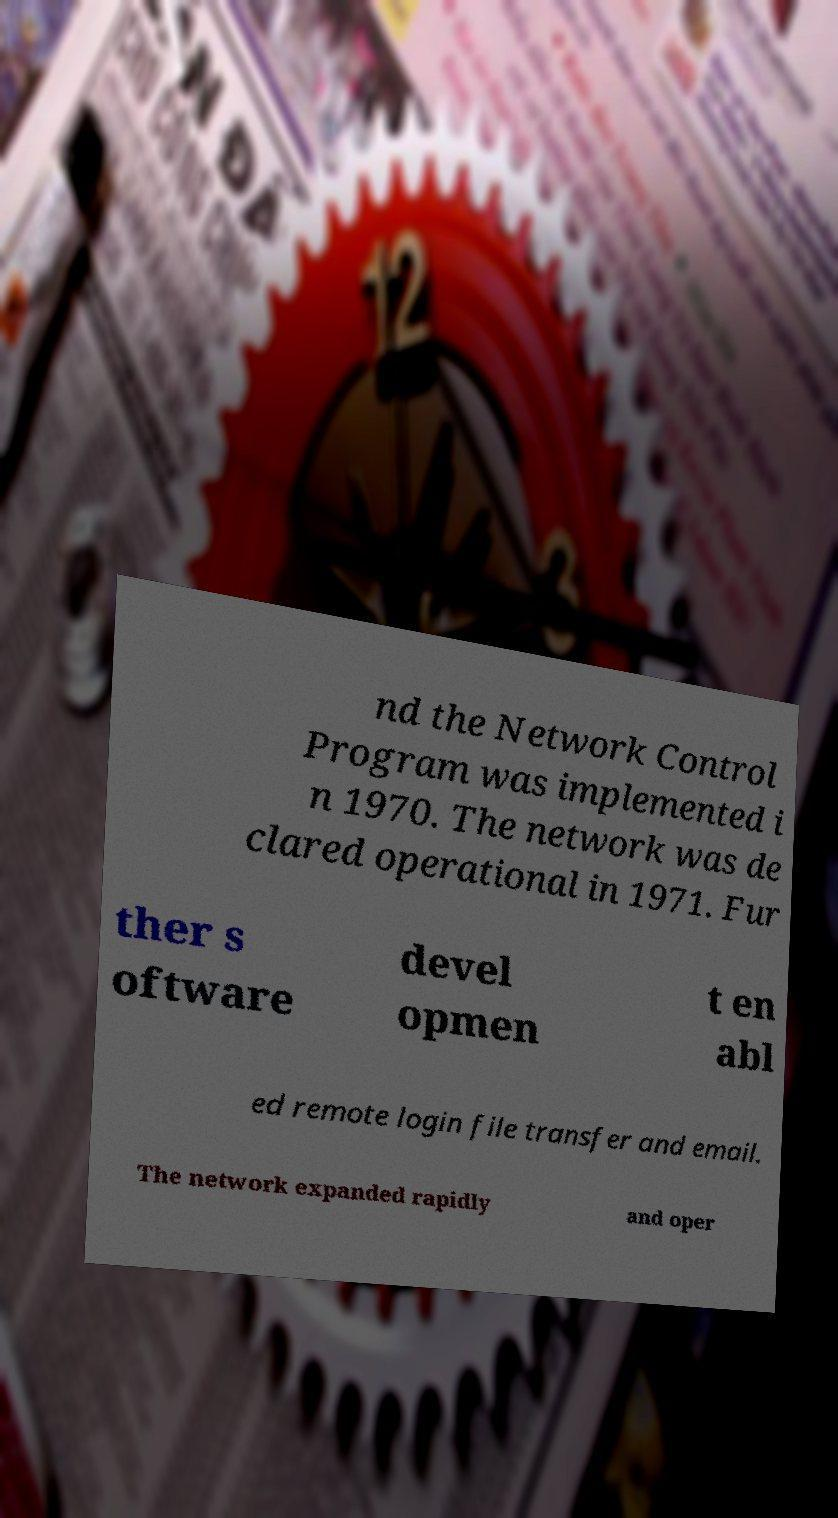Could you assist in decoding the text presented in this image and type it out clearly? nd the Network Control Program was implemented i n 1970. The network was de clared operational in 1971. Fur ther s oftware devel opmen t en abl ed remote login file transfer and email. The network expanded rapidly and oper 